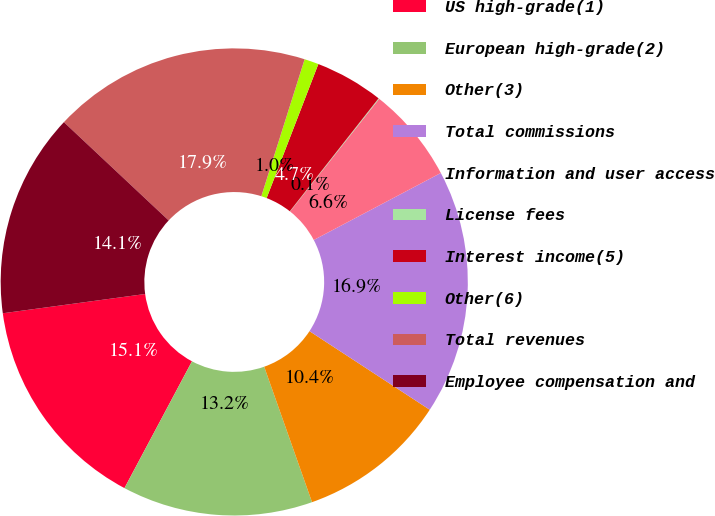Convert chart to OTSL. <chart><loc_0><loc_0><loc_500><loc_500><pie_chart><fcel>US high-grade(1)<fcel>European high-grade(2)<fcel>Other(3)<fcel>Total commissions<fcel>Information and user access<fcel>License fees<fcel>Interest income(5)<fcel>Other(6)<fcel>Total revenues<fcel>Employee compensation and<nl><fcel>15.07%<fcel>13.19%<fcel>10.38%<fcel>16.94%<fcel>6.62%<fcel>0.05%<fcel>4.74%<fcel>0.99%<fcel>17.88%<fcel>14.13%<nl></chart> 